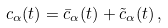Convert formula to latex. <formula><loc_0><loc_0><loc_500><loc_500>c _ { \alpha } ( t ) = \bar { c } _ { \alpha } ( t ) + \tilde { c } _ { \alpha } ( t ) \, ,</formula> 